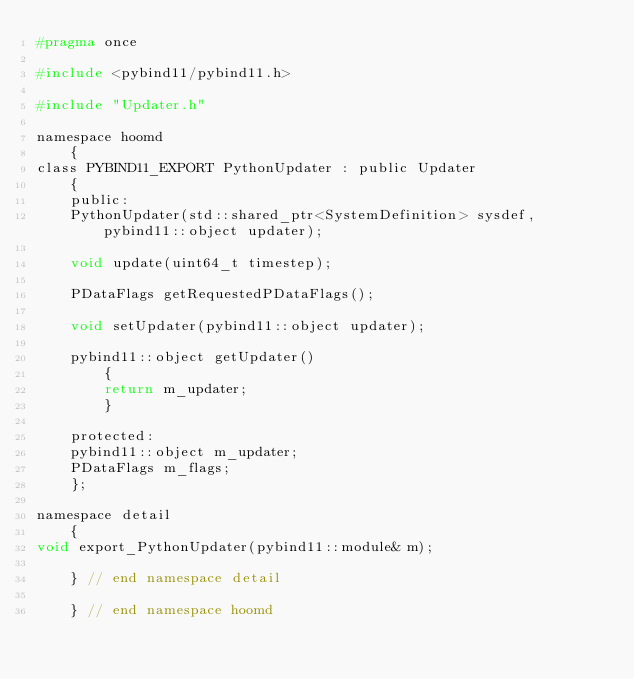Convert code to text. <code><loc_0><loc_0><loc_500><loc_500><_C_>#pragma once

#include <pybind11/pybind11.h>

#include "Updater.h"

namespace hoomd
    {
class PYBIND11_EXPORT PythonUpdater : public Updater
    {
    public:
    PythonUpdater(std::shared_ptr<SystemDefinition> sysdef, pybind11::object updater);

    void update(uint64_t timestep);

    PDataFlags getRequestedPDataFlags();

    void setUpdater(pybind11::object updater);

    pybind11::object getUpdater()
        {
        return m_updater;
        }

    protected:
    pybind11::object m_updater;
    PDataFlags m_flags;
    };

namespace detail
    {
void export_PythonUpdater(pybind11::module& m);

    } // end namespace detail

    } // end namespace hoomd
</code> 